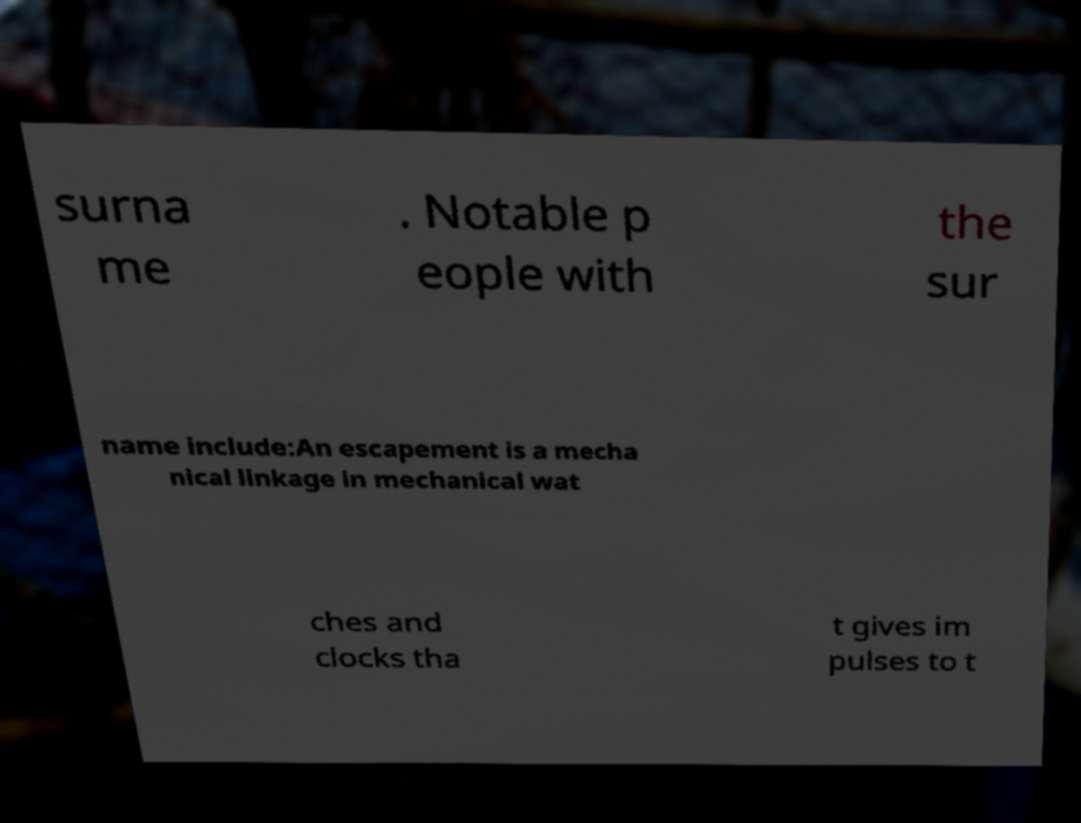Can you read and provide the text displayed in the image?This photo seems to have some interesting text. Can you extract and type it out for me? surna me . Notable p eople with the sur name include:An escapement is a mecha nical linkage in mechanical wat ches and clocks tha t gives im pulses to t 